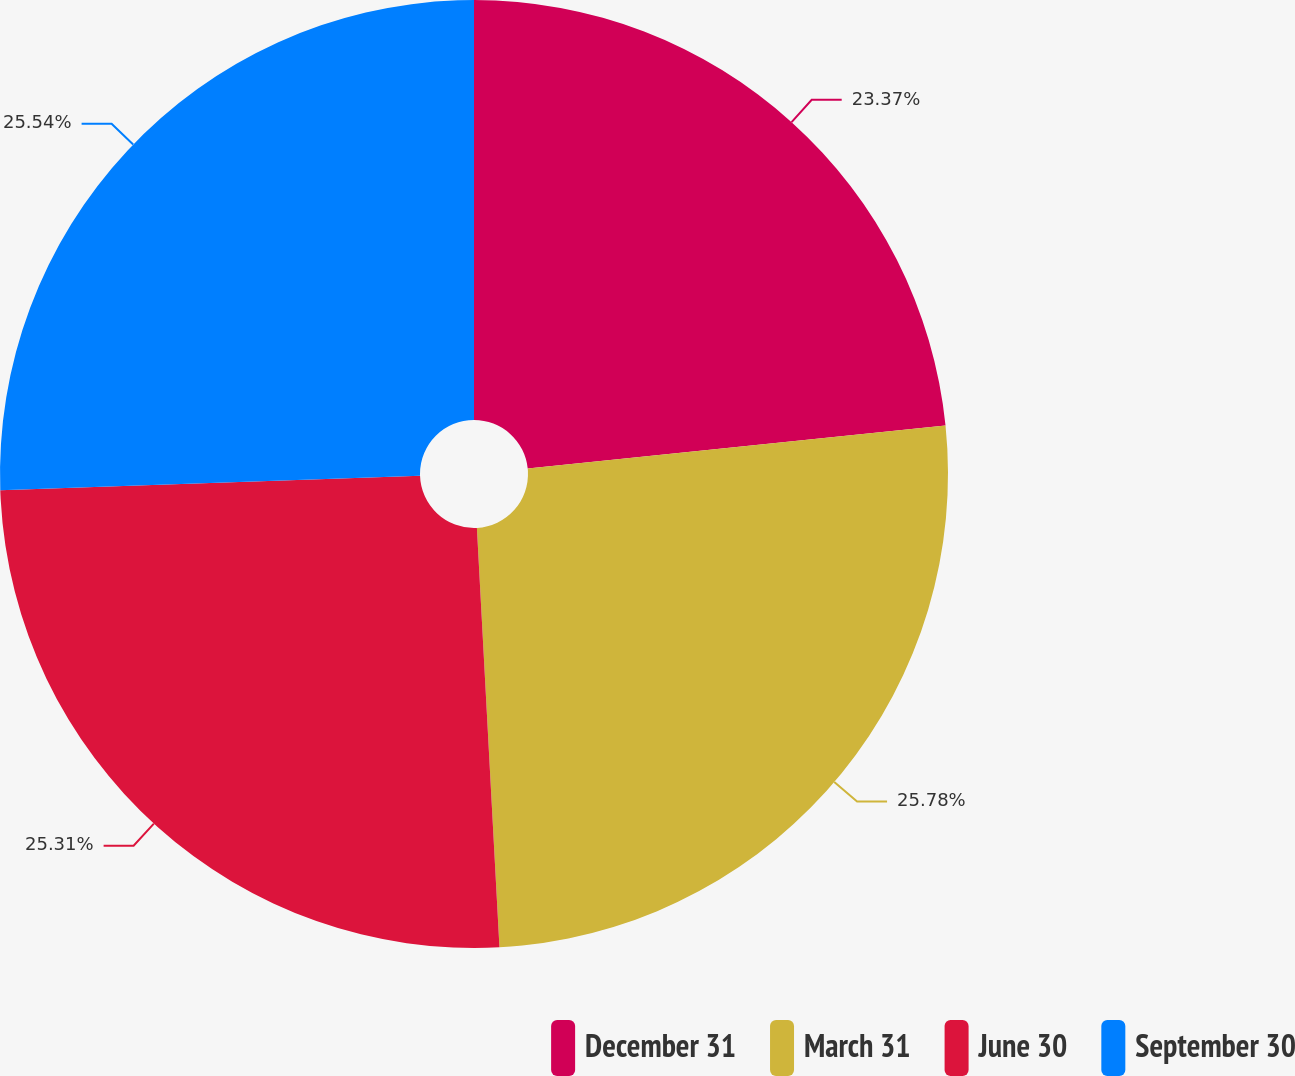Convert chart. <chart><loc_0><loc_0><loc_500><loc_500><pie_chart><fcel>December 31<fcel>March 31<fcel>June 30<fcel>September 30<nl><fcel>23.37%<fcel>25.77%<fcel>25.31%<fcel>25.54%<nl></chart> 